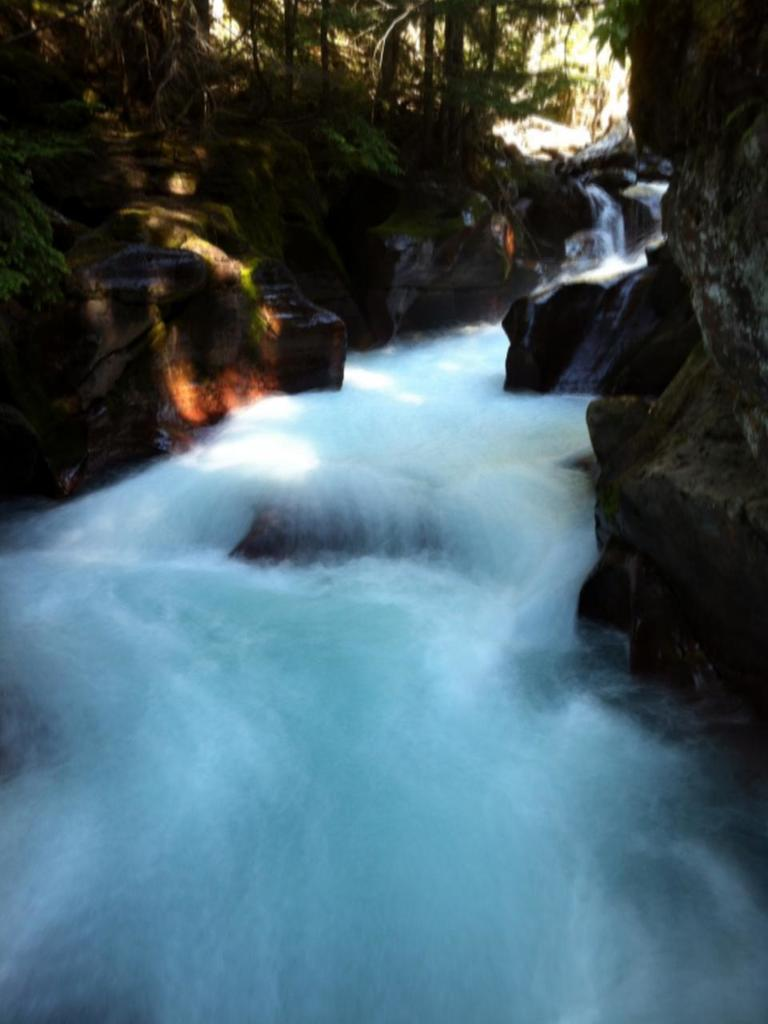What is present at the bottom of the image? There is water at the bottom of the image. What can be seen in the distance in the image? There are trees and rocks in the background of the image. What type of cart can be seen in the image? There is no cart present in the image. What kind of dirt is visible in the image? There is no dirt visible in the image; it features water, trees, and rocks. 